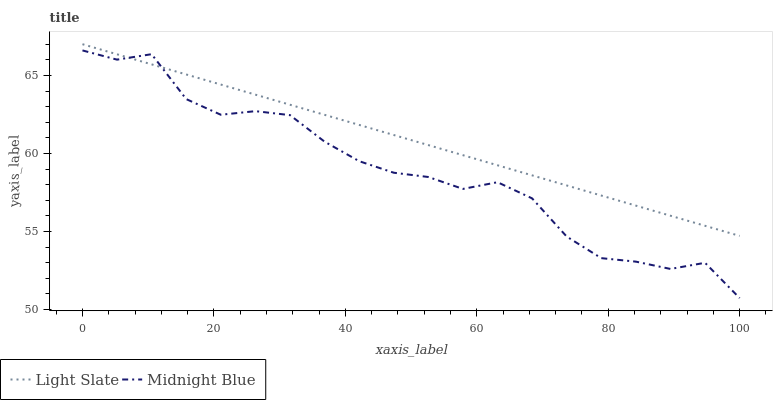Does Midnight Blue have the maximum area under the curve?
Answer yes or no. No. Is Midnight Blue the smoothest?
Answer yes or no. No. Does Midnight Blue have the highest value?
Answer yes or no. No. 